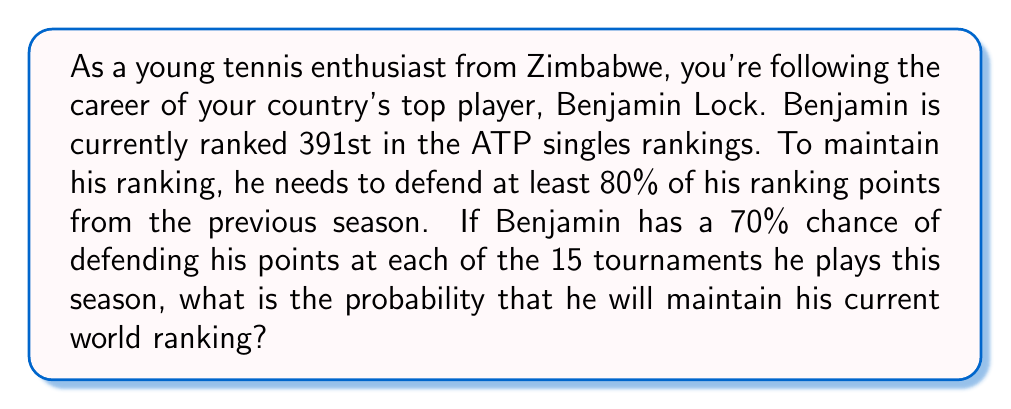Can you solve this math problem? Let's approach this step-by-step:

1) First, we need to understand what it means to maintain the ranking. Benjamin needs to defend at least 80% of his points in at least 12 out of 15 tournaments (since 12/15 = 80%).

2) This scenario follows a binomial probability distribution. We can use the binomial probability formula:

   $$P(X = k) = \binom{n}{k} p^k (1-p)^{n-k}$$

   Where:
   $n$ = total number of tournaments = 15
   $k$ = number of successful defenses needed = 12, 13, 14, or 15
   $p$ = probability of success in each tournament = 0.70

3) We need to calculate the probability of 12 or more successes:

   $$P(X \geq 12) = P(X = 12) + P(X = 13) + P(X = 14) + P(X = 15)$$

4) Let's calculate each term:

   $$P(X = 12) = \binom{15}{12} 0.70^{12} (1-0.70)^{15-12} = 0.1662$$
   $$P(X = 13) = \binom{15}{13} 0.70^{13} (1-0.70)^{15-13} = 0.0894$$
   $$P(X = 14) = \binom{15}{14} 0.70^{14} (1-0.70)^{15-14} = 0.0319$$
   $$P(X = 15) = \binom{15}{15} 0.70^{15} (1-0.70)^{15-15} = 0.0047$$

5) Sum these probabilities:

   $$P(X \geq 12) = 0.1662 + 0.0894 + 0.0319 + 0.0047 = 0.2922$$

Therefore, the probability that Benjamin will maintain his current world ranking is approximately 0.2922 or 29.22%.
Answer: The probability that Benjamin Lock will maintain his current world ranking is approximately 0.2922 or 29.22%. 